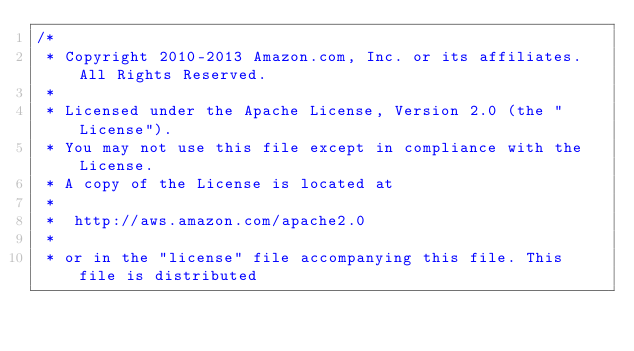<code> <loc_0><loc_0><loc_500><loc_500><_C_>/*
 * Copyright 2010-2013 Amazon.com, Inc. or its affiliates. All Rights Reserved.
 *
 * Licensed under the Apache License, Version 2.0 (the "License").
 * You may not use this file except in compliance with the License.
 * A copy of the License is located at
 *
 *  http://aws.amazon.com/apache2.0
 *
 * or in the "license" file accompanying this file. This file is distributed</code> 